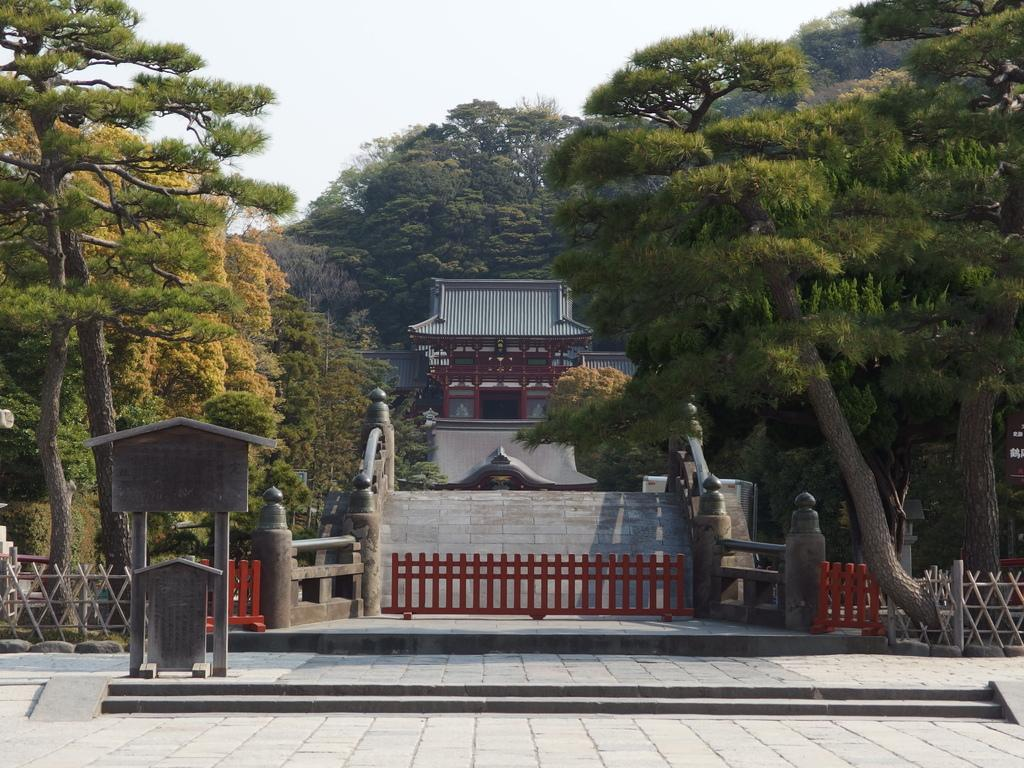What type of vegetation can be seen in the image? There are trees in the image. What type of structures are present in the image? There are houses in the image. What architectural feature can be seen in the image? There is a fence in the image. What type of barrier can be seen in the image? There is railing in the image. What surface is visible in the image? There is a floor in the image. What part of the natural environment is visible in the image? The sky is visible in the image. Can you tell me how many poisonous snakes are crawling on the floor in the image? There is no mention of poisonous snakes in the image; the facts provided do not mention any snakes. What type of cannon is present in the image? There is no cannon present in the image; the facts provided do not mention any cannons. 